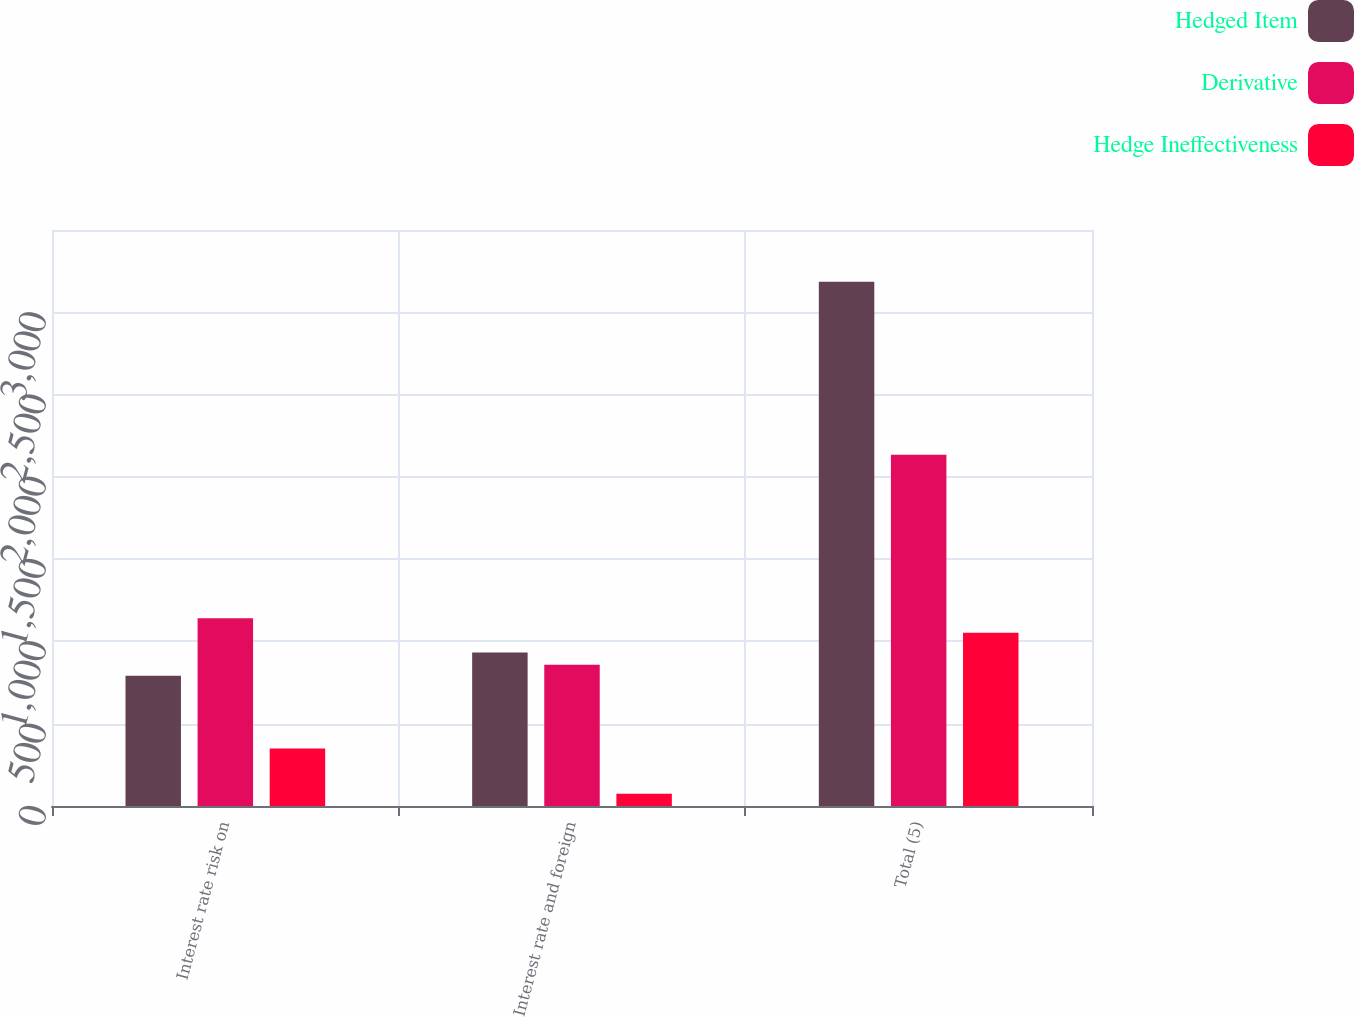<chart> <loc_0><loc_0><loc_500><loc_500><stacked_bar_chart><ecel><fcel>Interest rate risk on<fcel>Interest rate and foreign<fcel>Total (5)<nl><fcel>Hedged Item<fcel>791<fcel>932<fcel>3186<nl><fcel>Derivative<fcel>1141<fcel>858<fcel>2134<nl><fcel>Hedge Ineffectiveness<fcel>350<fcel>74<fcel>1052<nl></chart> 